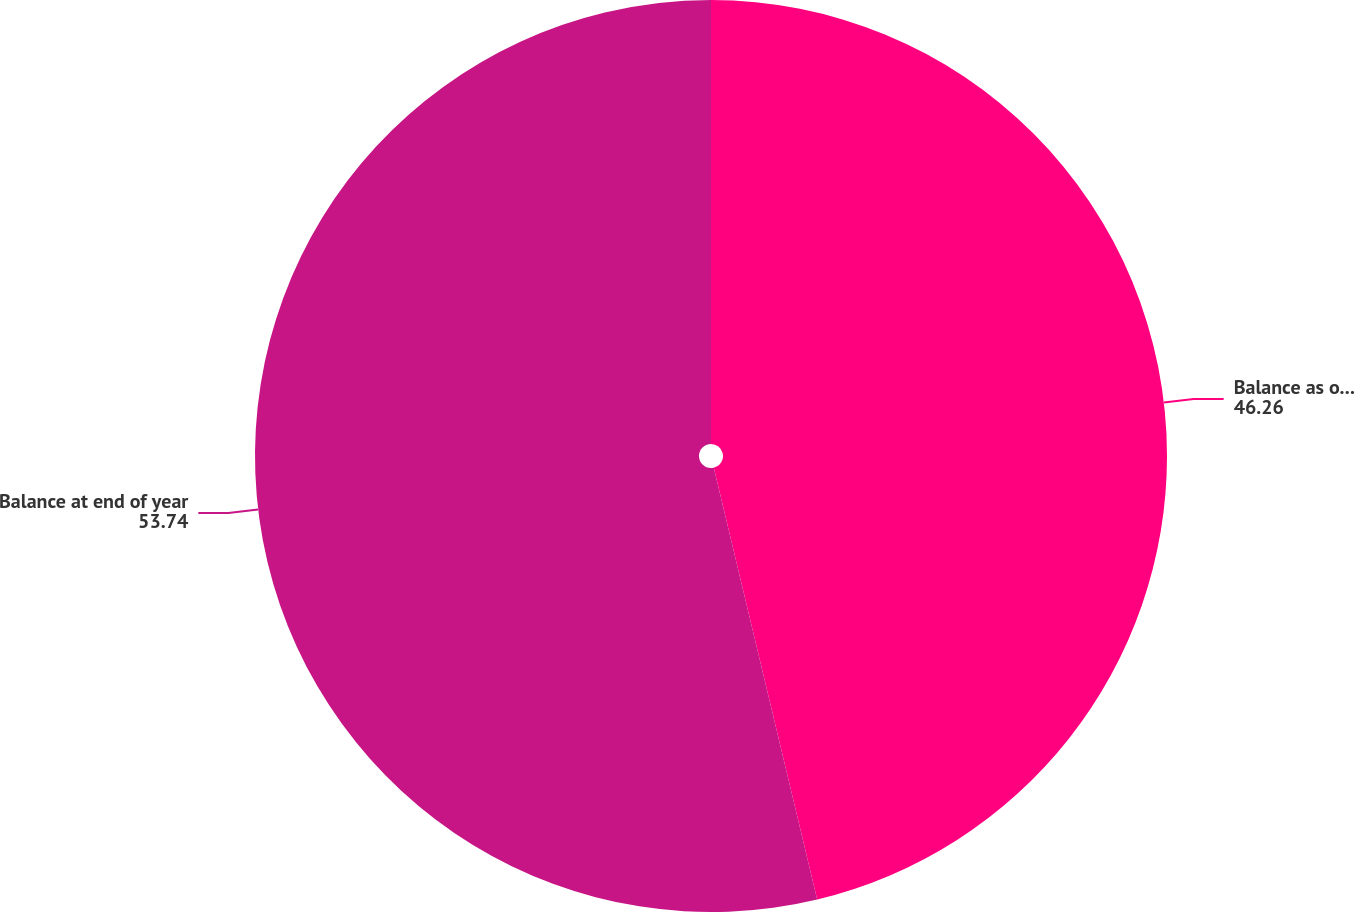<chart> <loc_0><loc_0><loc_500><loc_500><pie_chart><fcel>Balance as of January 1<fcel>Balance at end of year<nl><fcel>46.26%<fcel>53.74%<nl></chart> 